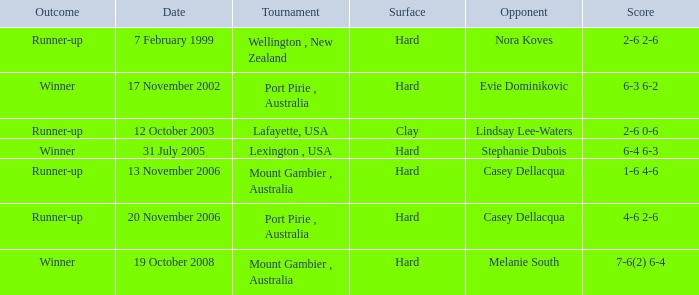Which is the Outcome on 13 november 2006? Runner-up. 